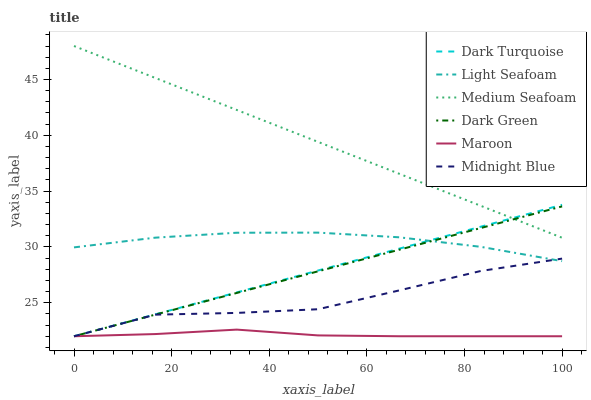Does Dark Turquoise have the minimum area under the curve?
Answer yes or no. No. Does Dark Turquoise have the maximum area under the curve?
Answer yes or no. No. Is Dark Turquoise the smoothest?
Answer yes or no. No. Is Dark Turquoise the roughest?
Answer yes or no. No. Does Light Seafoam have the lowest value?
Answer yes or no. No. Does Dark Turquoise have the highest value?
Answer yes or no. No. Is Light Seafoam less than Medium Seafoam?
Answer yes or no. Yes. Is Medium Seafoam greater than Midnight Blue?
Answer yes or no. Yes. Does Light Seafoam intersect Medium Seafoam?
Answer yes or no. No. 